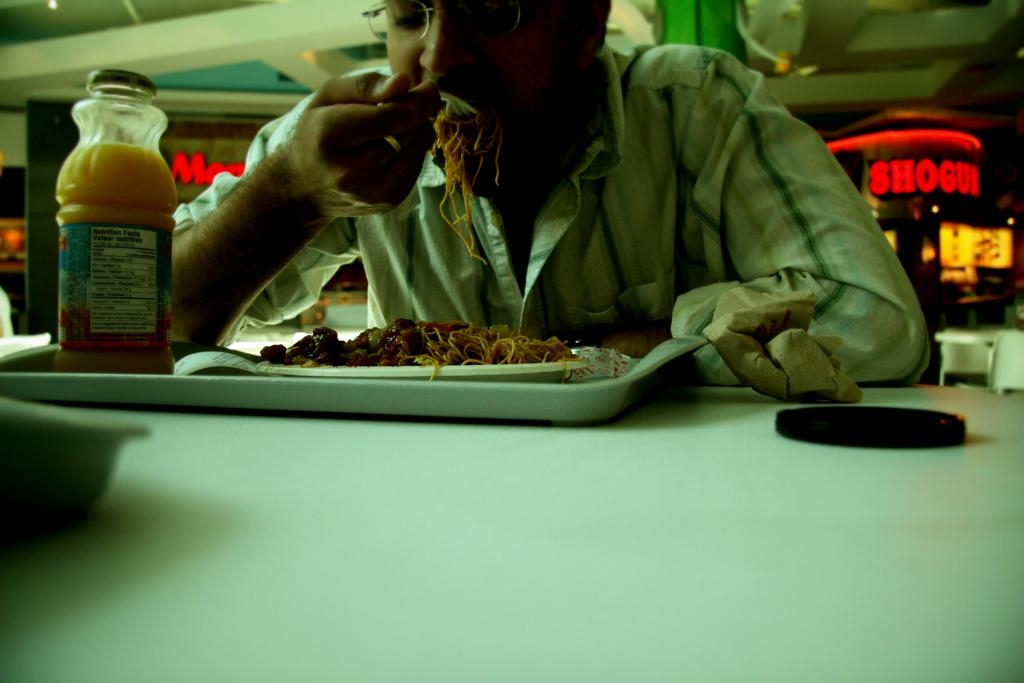Provide a one-sentence caption for the provided image. A man eating spaghetti with an oj bottle that has the nutrition facts on the label, in front of a sign for Shogun. 